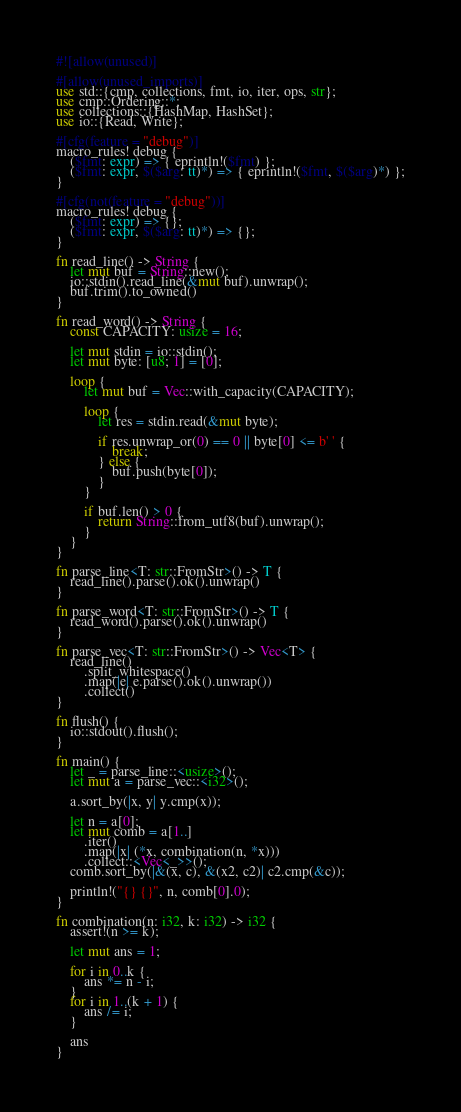<code> <loc_0><loc_0><loc_500><loc_500><_Rust_>#![allow(unused)]

#[allow(unused_imports)]
use std::{cmp, collections, fmt, io, iter, ops, str};
use cmp::Ordering::*;
use collections::{HashMap, HashSet};
use io::{Read, Write};

#[cfg(feature = "debug")]
macro_rules! debug {
    ($fmt: expr) => { eprintln!($fmt) };
    ($fmt: expr, $($arg: tt)*) => { eprintln!($fmt, $($arg)*) };
}

#[cfg(not(feature = "debug"))]
macro_rules! debug {
    ($fmt: expr) => {};
    ($fmt: expr, $($arg: tt)*) => {};
}

fn read_line() -> String {
    let mut buf = String::new();
    io::stdin().read_line(&mut buf).unwrap();
    buf.trim().to_owned()
}

fn read_word() -> String {
    const CAPACITY: usize = 16;

    let mut stdin = io::stdin();
    let mut byte: [u8; 1] = [0];

    loop {
        let mut buf = Vec::with_capacity(CAPACITY);

        loop {
            let res = stdin.read(&mut byte);

            if res.unwrap_or(0) == 0 || byte[0] <= b' ' {
                break;
            } else {
                buf.push(byte[0]);
            }
        }

        if buf.len() > 0 {
            return String::from_utf8(buf).unwrap();
        }
    }
}

fn parse_line<T: str::FromStr>() -> T {
    read_line().parse().ok().unwrap()
}

fn parse_word<T: str::FromStr>() -> T {
    read_word().parse().ok().unwrap()
}

fn parse_vec<T: str::FromStr>() -> Vec<T> {
    read_line()
        .split_whitespace()
        .map(|e| e.parse().ok().unwrap())
        .collect()
}

fn flush() {
    io::stdout().flush();
}

fn main() {
    let _ = parse_line::<usize>();
    let mut a = parse_vec::<i32>();

    a.sort_by(|x, y| y.cmp(x));

    let n = a[0];
    let mut comb = a[1..]
        .iter()
        .map(|x| (*x, combination(n, *x)))
        .collect::<Vec<_>>();
    comb.sort_by(|&(x, c), &(x2, c2)| c2.cmp(&c));

    println!("{} {}", n, comb[0].0);
}

fn combination(n: i32, k: i32) -> i32 {
    assert!(n >= k);

    let mut ans = 1;

    for i in 0..k {
        ans *= n - i;
    }
    for i in 1..(k + 1) {
        ans /= i;
    }

    ans
}</code> 